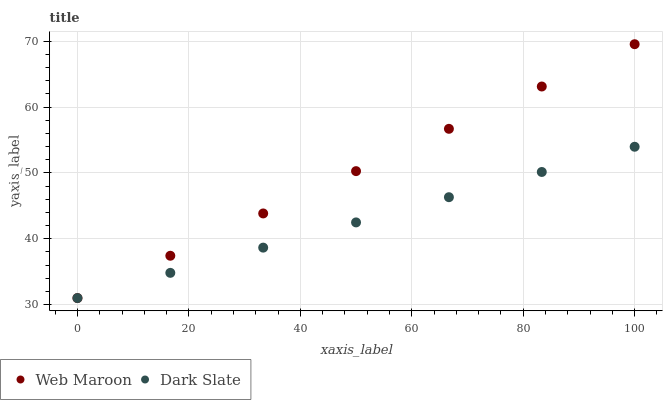Does Dark Slate have the minimum area under the curve?
Answer yes or no. Yes. Does Web Maroon have the maximum area under the curve?
Answer yes or no. Yes. Does Web Maroon have the minimum area under the curve?
Answer yes or no. No. Is Dark Slate the smoothest?
Answer yes or no. Yes. Is Web Maroon the roughest?
Answer yes or no. Yes. Is Web Maroon the smoothest?
Answer yes or no. No. Does Dark Slate have the lowest value?
Answer yes or no. Yes. Does Web Maroon have the highest value?
Answer yes or no. Yes. Does Web Maroon intersect Dark Slate?
Answer yes or no. Yes. Is Web Maroon less than Dark Slate?
Answer yes or no. No. Is Web Maroon greater than Dark Slate?
Answer yes or no. No. 